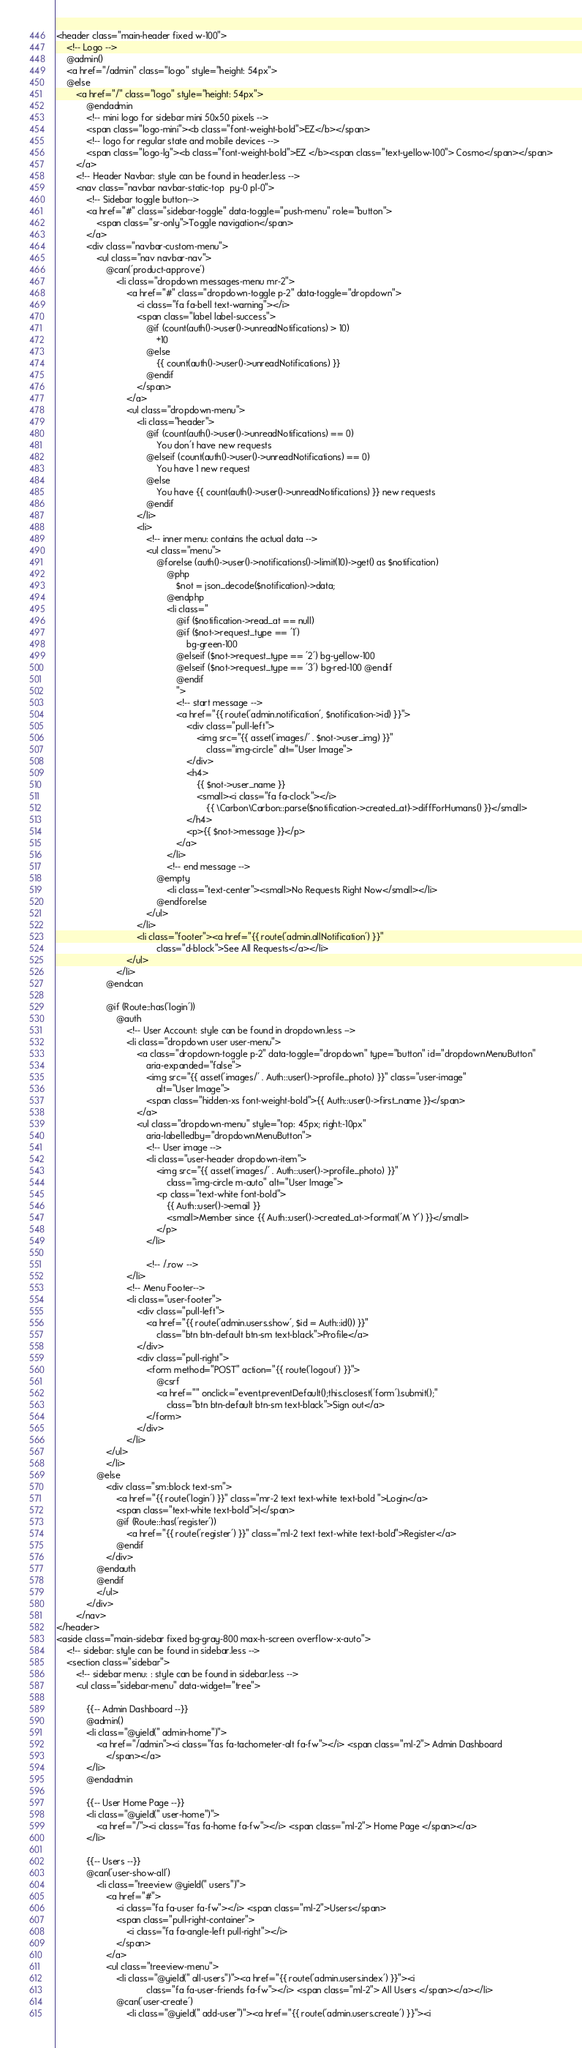<code> <loc_0><loc_0><loc_500><loc_500><_PHP_><header class="main-header fixed w-100">
    <!-- Logo -->
    @admin()
    <a href="/admin" class="logo" style="height: 54px">
    @else
        <a href="/" class="logo" style="height: 54px">
            @endadmin
            <!-- mini logo for sidebar mini 50x50 pixels -->
            <span class="logo-mini"><b class="font-weight-bold">EZ</b></span>
            <!-- logo for regular state and mobile devices -->
            <span class="logo-lg"><b class="font-weight-bold">EZ </b><span class="text-yellow-100"> Cosmo</span></span>
        </a>
        <!-- Header Navbar: style can be found in header.less -->
        <nav class="navbar navbar-static-top  py-0 pl-0">
            <!-- Sidebar toggle button-->
            <a href="#" class="sidebar-toggle" data-toggle="push-menu" role="button">
                <span class="sr-only">Toggle navigation</span>
            </a>
            <div class="navbar-custom-menu">
                <ul class="nav navbar-nav">
                    @can('product-approve')
                        <li class="dropdown messages-menu mr-2">
                            <a href="#" class="dropdown-toggle p-2" data-toggle="dropdown">
                                <i class="fa fa-bell text-warning"></i>
                                <span class="label label-success">
                                    @if (count(auth()->user()->unreadNotifications) > 10)
                                        +10
                                    @else
                                        {{ count(auth()->user()->unreadNotifications) }}
                                    @endif
                                </span>
                            </a>
                            <ul class="dropdown-menu">
                                <li class="header">
                                    @if (count(auth()->user()->unreadNotifications) == 0)
                                        You don't have new requests
                                    @elseif (count(auth()->user()->unreadNotifications) == 0)
                                        You have 1 new request
                                    @else
                                        You have {{ count(auth()->user()->unreadNotifications) }} new requests
                                    @endif
                                </li>
                                <li>
                                    <!-- inner menu: contains the actual data -->
                                    <ul class="menu">
                                        @forelse (auth()->user()->notifications()->limit(10)->get() as $notification)
                                            @php
                                                $not = json_decode($notification)->data;
                                            @endphp
                                            <li class="
                                                @if ($notification->read_at == null) 
                                                @if ($not->request_type == '1')
                                                    bg-green-100
                                                @elseif ($not->request_type == '2') bg-yellow-100
                                                @elseif ($not->request_type == '3') bg-red-100 @endif
                                                @endif
                                                ">
                                                <!-- start message -->
                                                <a href="{{ route('admin.notification', $notification->id) }}">
                                                    <div class="pull-left">
                                                        <img src="{{ asset('images/' . $not->user_img) }}"
                                                            class="img-circle" alt="User Image">
                                                    </div>
                                                    <h4>
                                                        {{ $not->user_name }}
                                                        <small><i class="fa fa-clock"></i>
                                                            {{ \Carbon\Carbon::parse($notification->created_at)->diffForHumans() }}</small>
                                                    </h4>
                                                    <p>{{ $not->message }}</p>
                                                </a>
                                            </li>
                                            <!-- end message -->
                                        @empty
                                            <li class="text-center"><small>No Requests Right Now</small></li>
                                        @endforelse
                                    </ul>
                                </li>
                                <li class="footer"><a href="{{ route('admin.allNotification') }}"
                                        class="d-block">See All Requests</a></li>
                            </ul>
                        </li>
                    @endcan

                    @if (Route::has('login'))
                        @auth
                            <!-- User Account: style can be found in dropdown.less -->
                            <li class="dropdown user user-menu">
                                <a class="dropdown-toggle p-2" data-toggle="dropdown" type="button" id="dropdownMenuButton"
                                    aria-expanded="false">
                                    <img src="{{ asset('images/' . Auth::user()->profile_photo) }}" class="user-image"
                                        alt="User Image">
                                    <span class="hidden-xs font-weight-bold">{{ Auth::user()->first_name }}</span>
                                </a>
                                <ul class="dropdown-menu" style="top: 45px; right:-10px"
                                    aria-labelledby="dropdownMenuButton">
                                    <!-- User image -->
                                    <li class="user-header dropdown-item">
                                        <img src="{{ asset('images/' . Auth::user()->profile_photo) }}"
                                            class="img-circle m-auto" alt="User Image">
                                        <p class="text-white font-bold">
                                            {{ Auth::user()->email }}
                                            <small>Member since {{ Auth::user()->created_at->format('M Y') }}</small>
                                        </p>
                                    </li>

                                    <!-- /.row -->
                            </li>
                            <!-- Menu Footer-->
                            <li class="user-footer">
                                <div class="pull-left">
                                    <a href="{{ route('admin.users.show', $id = Auth::id()) }}"
                                        class="btn btn-default btn-sm text-black">Profile</a>
                                </div>
                                <div class="pull-right">
                                    <form method="POST" action="{{ route('logout') }}">
                                        @csrf
                                        <a href="" onclick="event.preventDefault();this.closest('form').submit();"
                                            class="btn btn-default btn-sm text-black">Sign out</a>
                                    </form>
                                </div>
                            </li>
                    </ul>
                    </li>
                @else
                    <div class="sm:block text-sm">
                        <a href="{{ route('login') }}" class="mr-2 text text-white text-bold ">Login</a>
                        <span class="text-white text-bold">|</span>
                        @if (Route::has('register'))
                            <a href="{{ route('register') }}" class="ml-2 text text-white text-bold">Register</a>
                        @endif
                    </div>
                @endauth
                @endif
                </ul>
            </div>
        </nav>
</header>
<aside class="main-sidebar fixed bg-gray-800 max-h-screen overflow-x-auto">
    <!-- sidebar: style can be found in sidebar.less -->
    <section class="sidebar">
        <!-- sidebar menu: : style can be found in sidebar.less -->
        <ul class="sidebar-menu" data-widget="tree">

            {{-- Admin Dashboard --}}
            @admin()
            <li class="@yield(" admin-home")">
                <a href="/admin"><i class="fas fa-tachometer-alt fa-fw"></i> <span class="ml-2"> Admin Dashboard
                    </span></a>
            </li>
            @endadmin

            {{-- User Home Page --}}
            <li class="@yield(" user-home")">
                <a href="/"><i class="fas fa-home fa-fw"></i> <span class="ml-2"> Home Page </span></a>
            </li>

            {{-- Users --}}
            @can('user-show-all')
                <li class="treeview @yield(" users")">
                    <a href="#">
                        <i class="fa fa-user fa-fw"></i> <span class="ml-2">Users</span>
                        <span class="pull-right-container">
                            <i class="fa fa-angle-left pull-right"></i>
                        </span>
                    </a>
                    <ul class="treeview-menu">
                        <li class="@yield(" all-users")"><a href="{{ route('admin.users.index') }}"><i
                                    class="fa fa-user-friends fa-fw"></i> <span class="ml-2"> All Users </span></a></li>
                        @can('user-create')
                            <li class="@yield(" add-user")"><a href="{{ route('admin.users.create') }}"><i</code> 